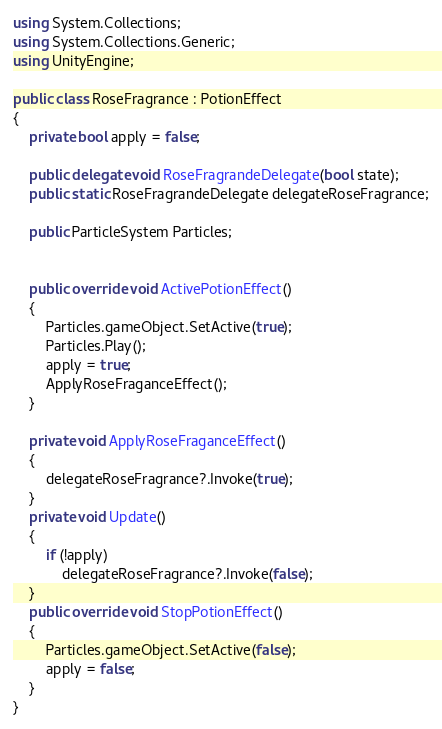Convert code to text. <code><loc_0><loc_0><loc_500><loc_500><_C#_>using System.Collections;
using System.Collections.Generic;
using UnityEngine;

public class RoseFragrance : PotionEffect
{
    private bool apply = false;

    public delegate void RoseFragrandeDelegate(bool state);
    public static RoseFragrandeDelegate delegateRoseFragrance;

    public ParticleSystem Particles;


    public override void ActivePotionEffect()
    {
        Particles.gameObject.SetActive(true);
        Particles.Play();
        apply = true;
        ApplyRoseFraganceEffect();
    }

    private void ApplyRoseFraganceEffect()
    {
        delegateRoseFragrance?.Invoke(true);
    }
    private void Update()
    {
        if (!apply)
            delegateRoseFragrance?.Invoke(false);
    }
    public override void StopPotionEffect()
    {
        Particles.gameObject.SetActive(false);
        apply = false;
    }
}
</code> 